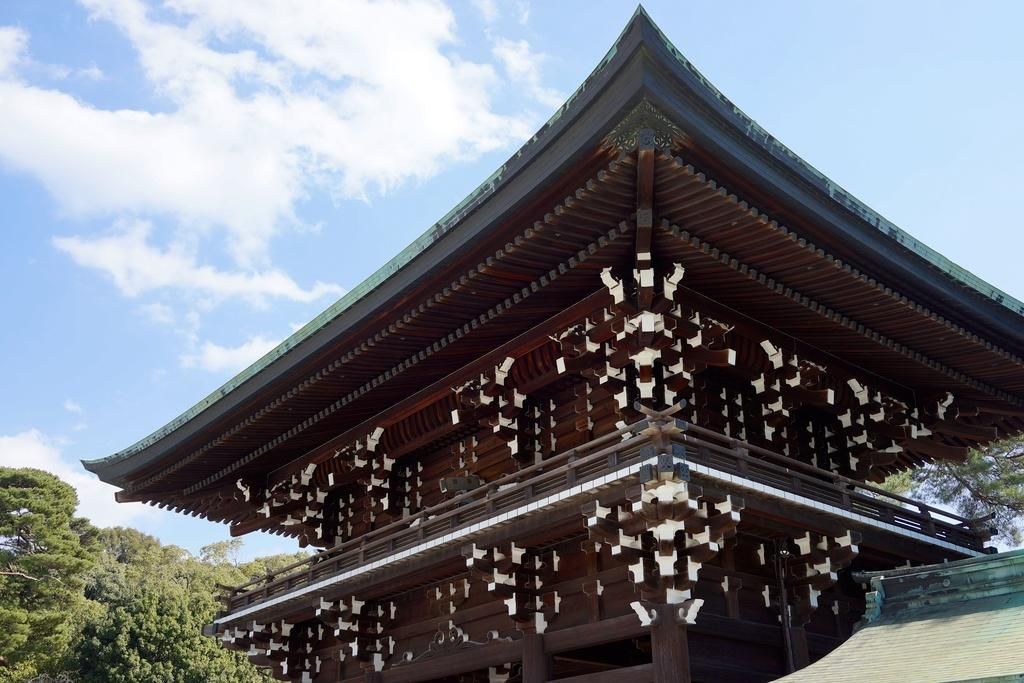What type of structures can be seen in the image? There are buildings in the image. What type of vegetation is present in the image? There are trees in the image. What is visible in the background of the image? The sky is visible in the image. What can be seen in the sky in the image? There are clouds in the sky. What type of twist can be seen in the image? There is no twist present in the image. What is the secretary doing in the image? There is no secretary present in the image. 